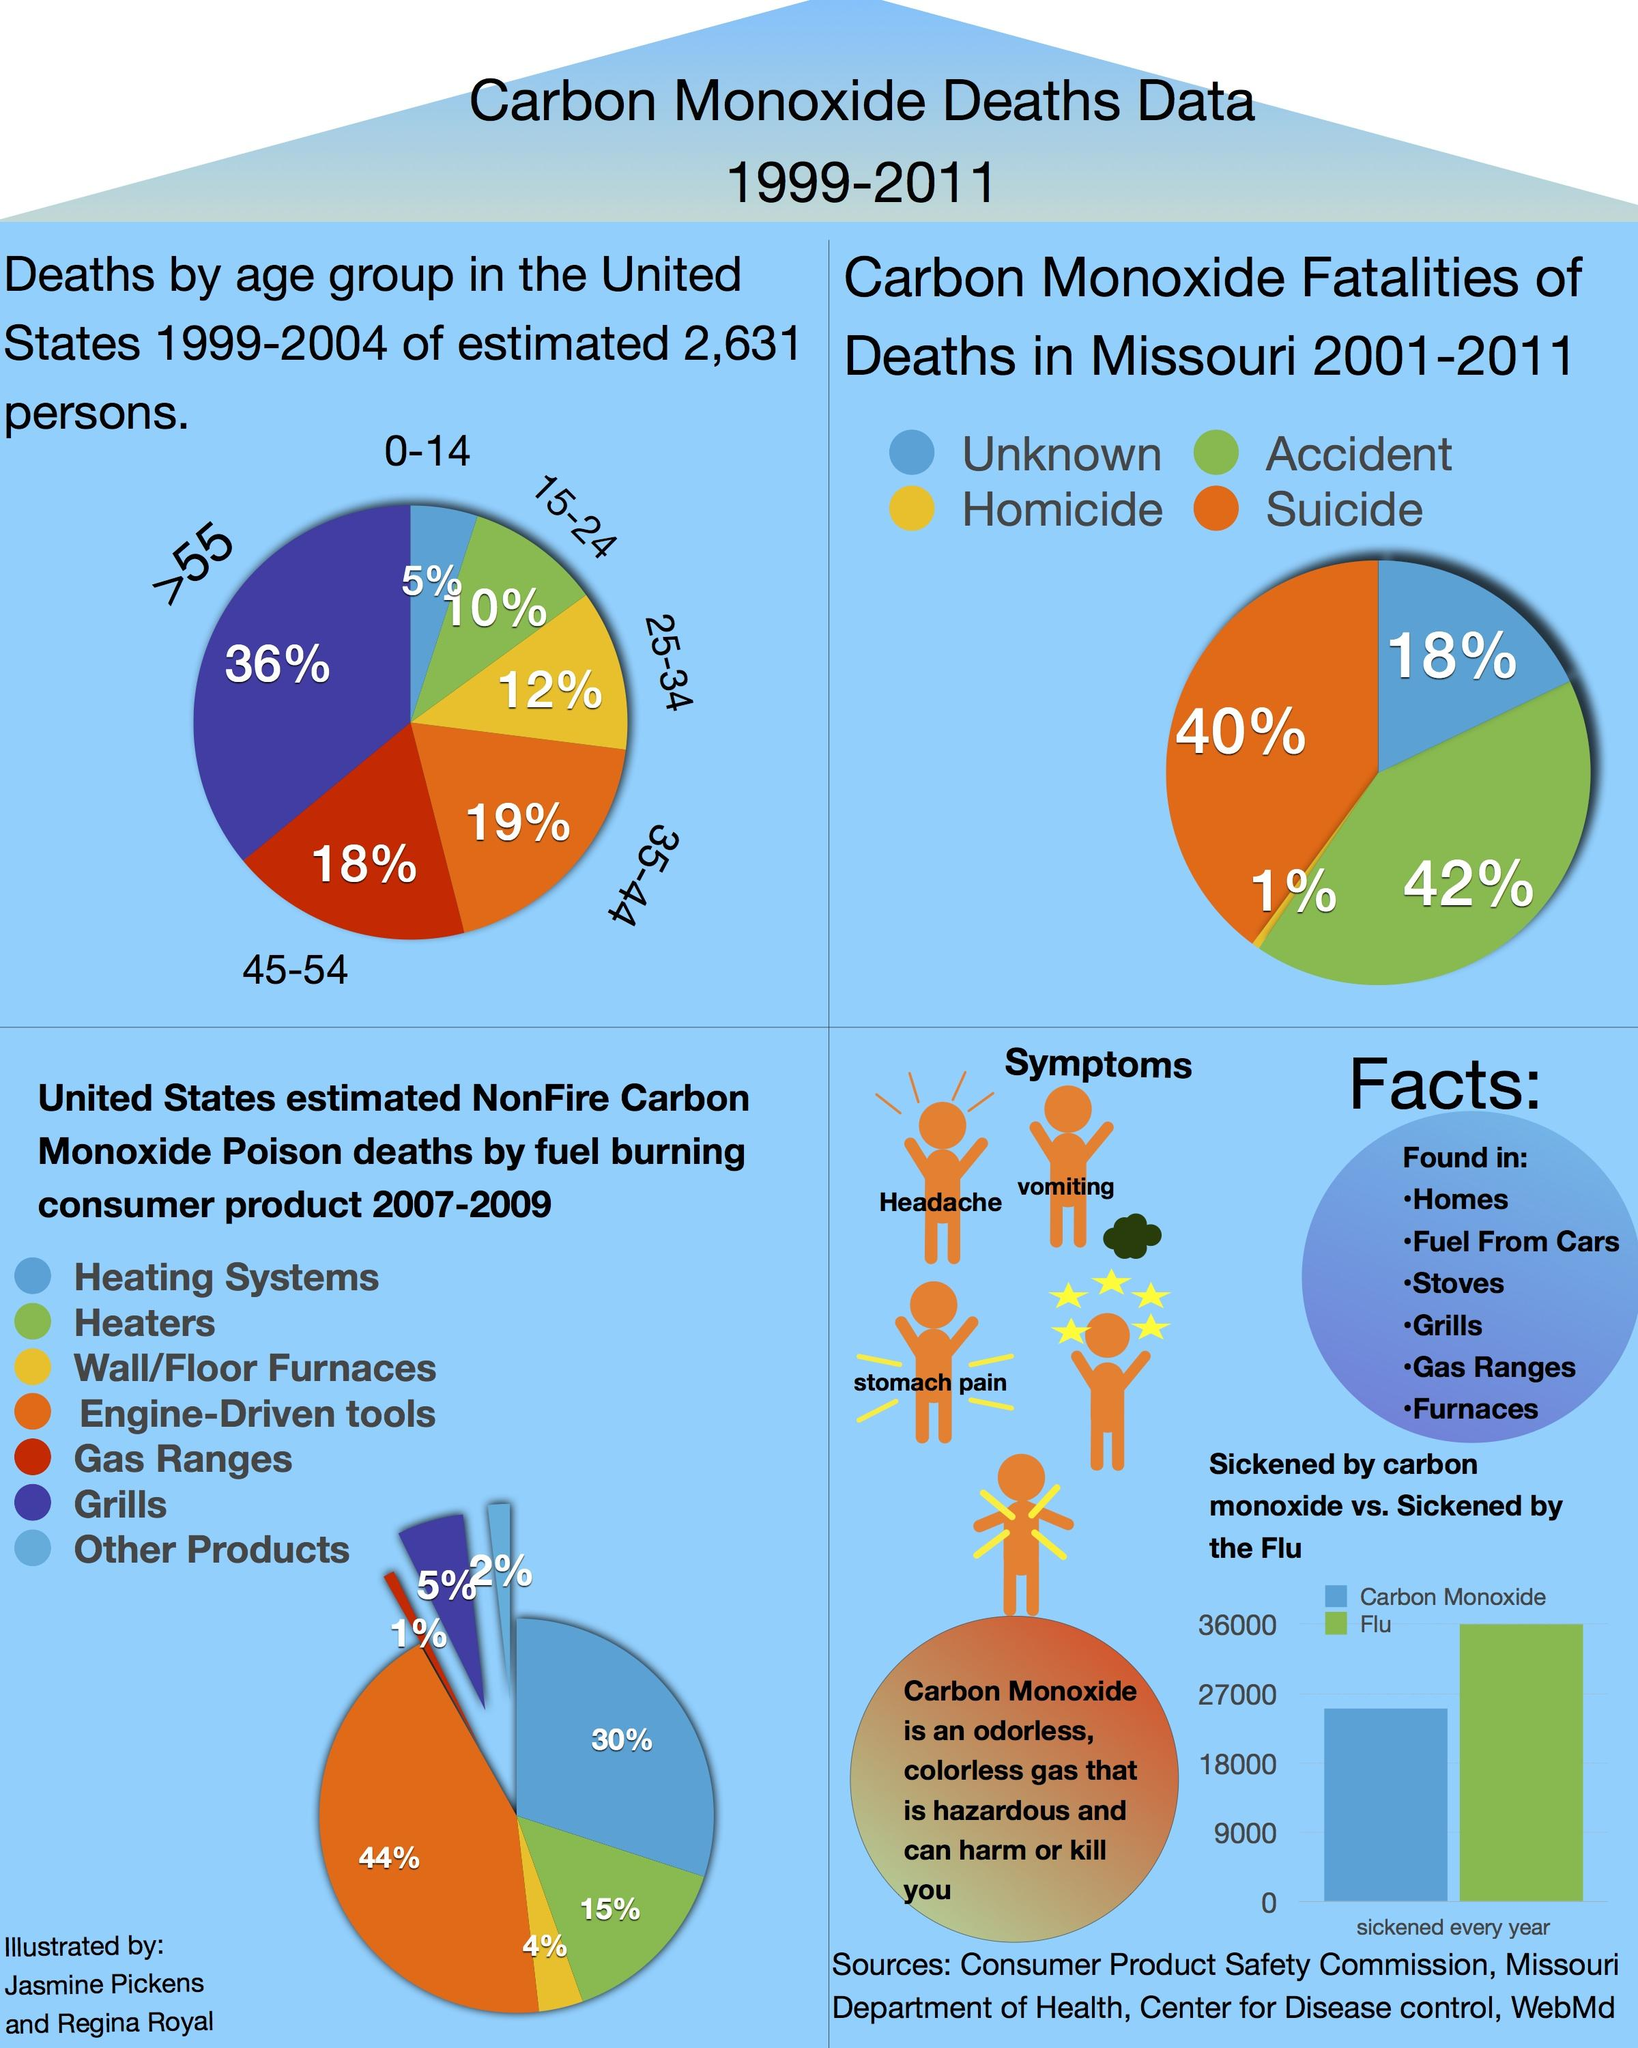Indicate a few pertinent items in this graphic. The second lowest percentage of death was 10%. Only 1% of carbon monoxide deaths in Missouri are the result of homicide. The symptoms of carbon monoxide poisoning, including headache, vomiting, and stomach pain, are commonly experienced by individuals who have been exposed to high levels of this toxic gas. It is estimated that over 11,000 people in the United States become ill due to the flu each year, while only a small fraction of that number, approximately 200, are affected by carbon monoxide poisoning. A significant 31% of individuals between the ages of 25 and 44 die due to carbon monoxide poisoning. 